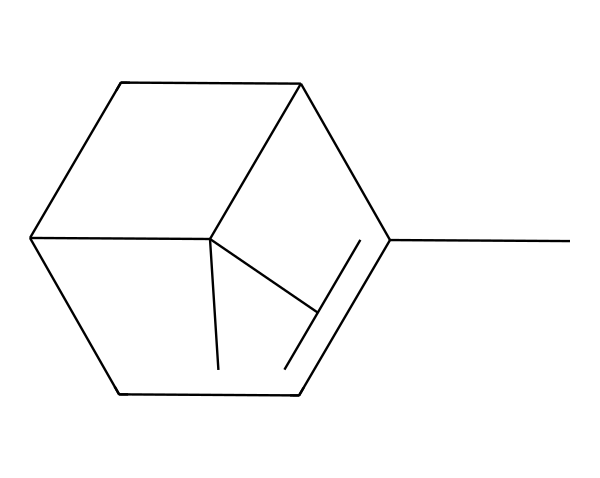What is the common name for this compound? The SMILES representation corresponds to pinene, which is a well-known terpene commonly found in pine resin.
Answer: pinene How many carbon atoms are present in the structure? By analyzing the SMILES, we can see that there are ten carbon atoms in total; they are indicated by the letter "C" in the representation.
Answer: ten What type of terpenoid is pinene classified as? Pinene is classified as a bicyclic monoterpene due to its two fused rings and the fact that it contains ten carbon atoms.
Answer: bicyclic monoterpene How many double bonds are present in the molecule? Looking at the structure represented in the SMILES, there are two double bonds identified in the framework of the molecule.
Answer: two Is the molecular structure of pinene symmetric? Upon examination of the chemical structure, one can observe that there are asymmetries in the arrangement of the substituents on the rings, indicating that it is not symmetric.
Answer: no Which functional groups are present in this structure? The primary functional group is the double bond, specifically alkene, which is characterized by the presence of the C=C bonds in the structure.
Answer: alkene 